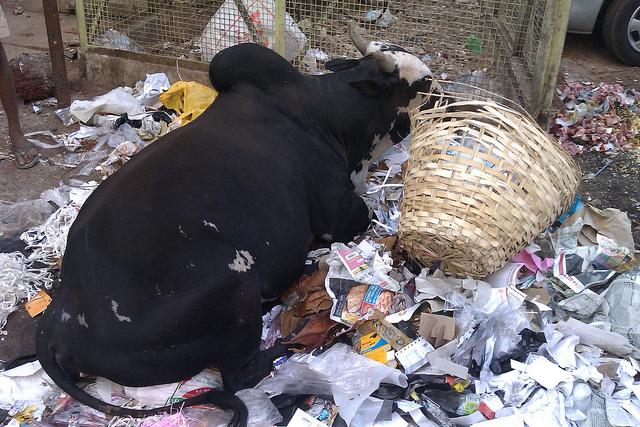Is this animal underweight?
Write a very short answer. No. What is this animal laying on?
Concise answer only. Trash. What animal is this?
Keep it brief. Cow. 